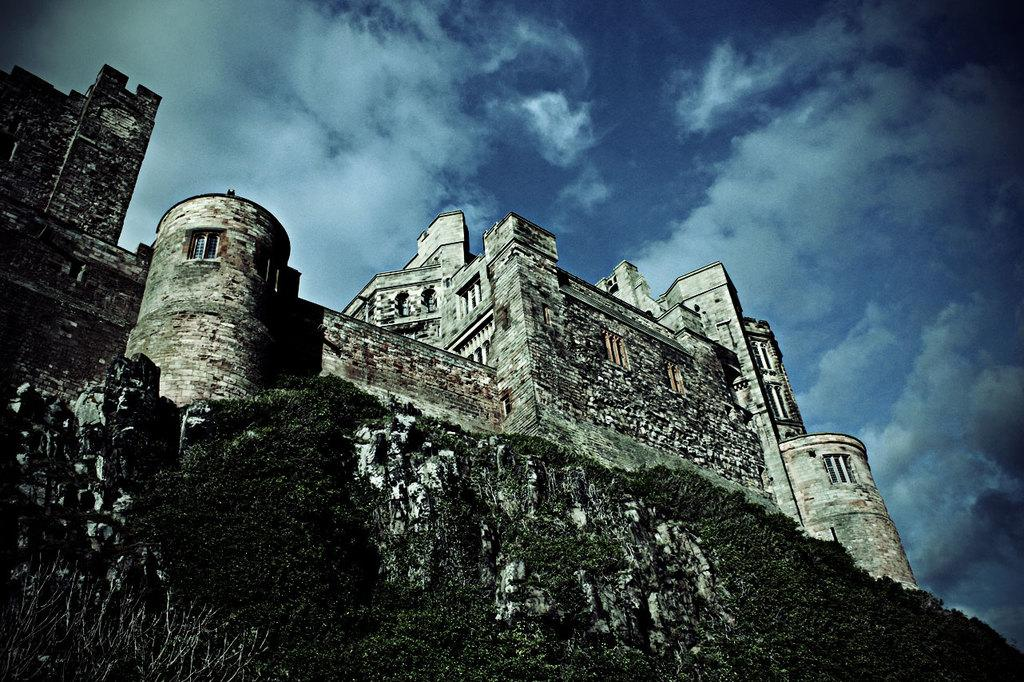What type of structure is visible in the image? There is a stone structure in the image. Where is the stone structure located? The stone structure is on a mountain. What is visible at the top of the image? The sky is visible at the top of the image. What can be seen in the sky? Clouds are present in the sky. What type of tax is being collected at the stone structure in the image? There is no mention of tax or any form of collection in the image; it features a stone structure on a mountain with clouds in the sky. 